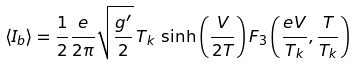<formula> <loc_0><loc_0><loc_500><loc_500>\langle I _ { b } \rangle = \frac { 1 } { 2 } \frac { e } { 2 \pi } \sqrt { \frac { g ^ { \prime } } { 2 } } \, T _ { k } \, \sinh \left ( \frac { V } { 2 T } \right ) F _ { 3 } \left ( { \frac { e V } { T _ { k } } } , { \frac { T } { T _ { k } } } \right )</formula> 